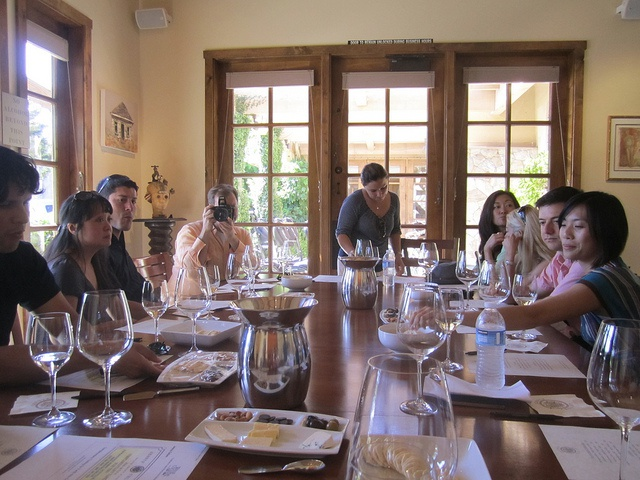Describe the objects in this image and their specific colors. I can see dining table in brown, darkgray, gray, black, and maroon tones, people in maroon, black, gray, and darkgray tones, wine glass in brown, darkgray, and gray tones, people in maroon, black, and gray tones, and people in brown, black, gray, and maroon tones in this image. 